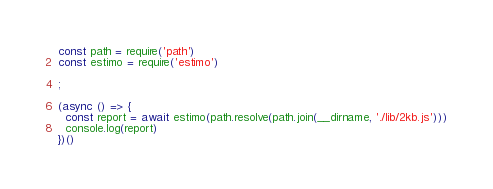Convert code to text. <code><loc_0><loc_0><loc_500><loc_500><_JavaScript_>const path = require('path')
const estimo = require('estimo')

;

(async () => {
  const report = await estimo(path.resolve(path.join(__dirname, './lib/2kb.js')))
  console.log(report)
})()
</code> 